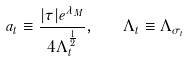Convert formula to latex. <formula><loc_0><loc_0><loc_500><loc_500>a _ { t } \equiv \frac { | \tau | e ^ { \lambda _ { M } } } { 4 \Lambda _ { t } ^ { \frac { 1 } { 2 } } } , \text { \ \ } \Lambda _ { t } \equiv \Lambda _ { \sigma _ { t } }</formula> 